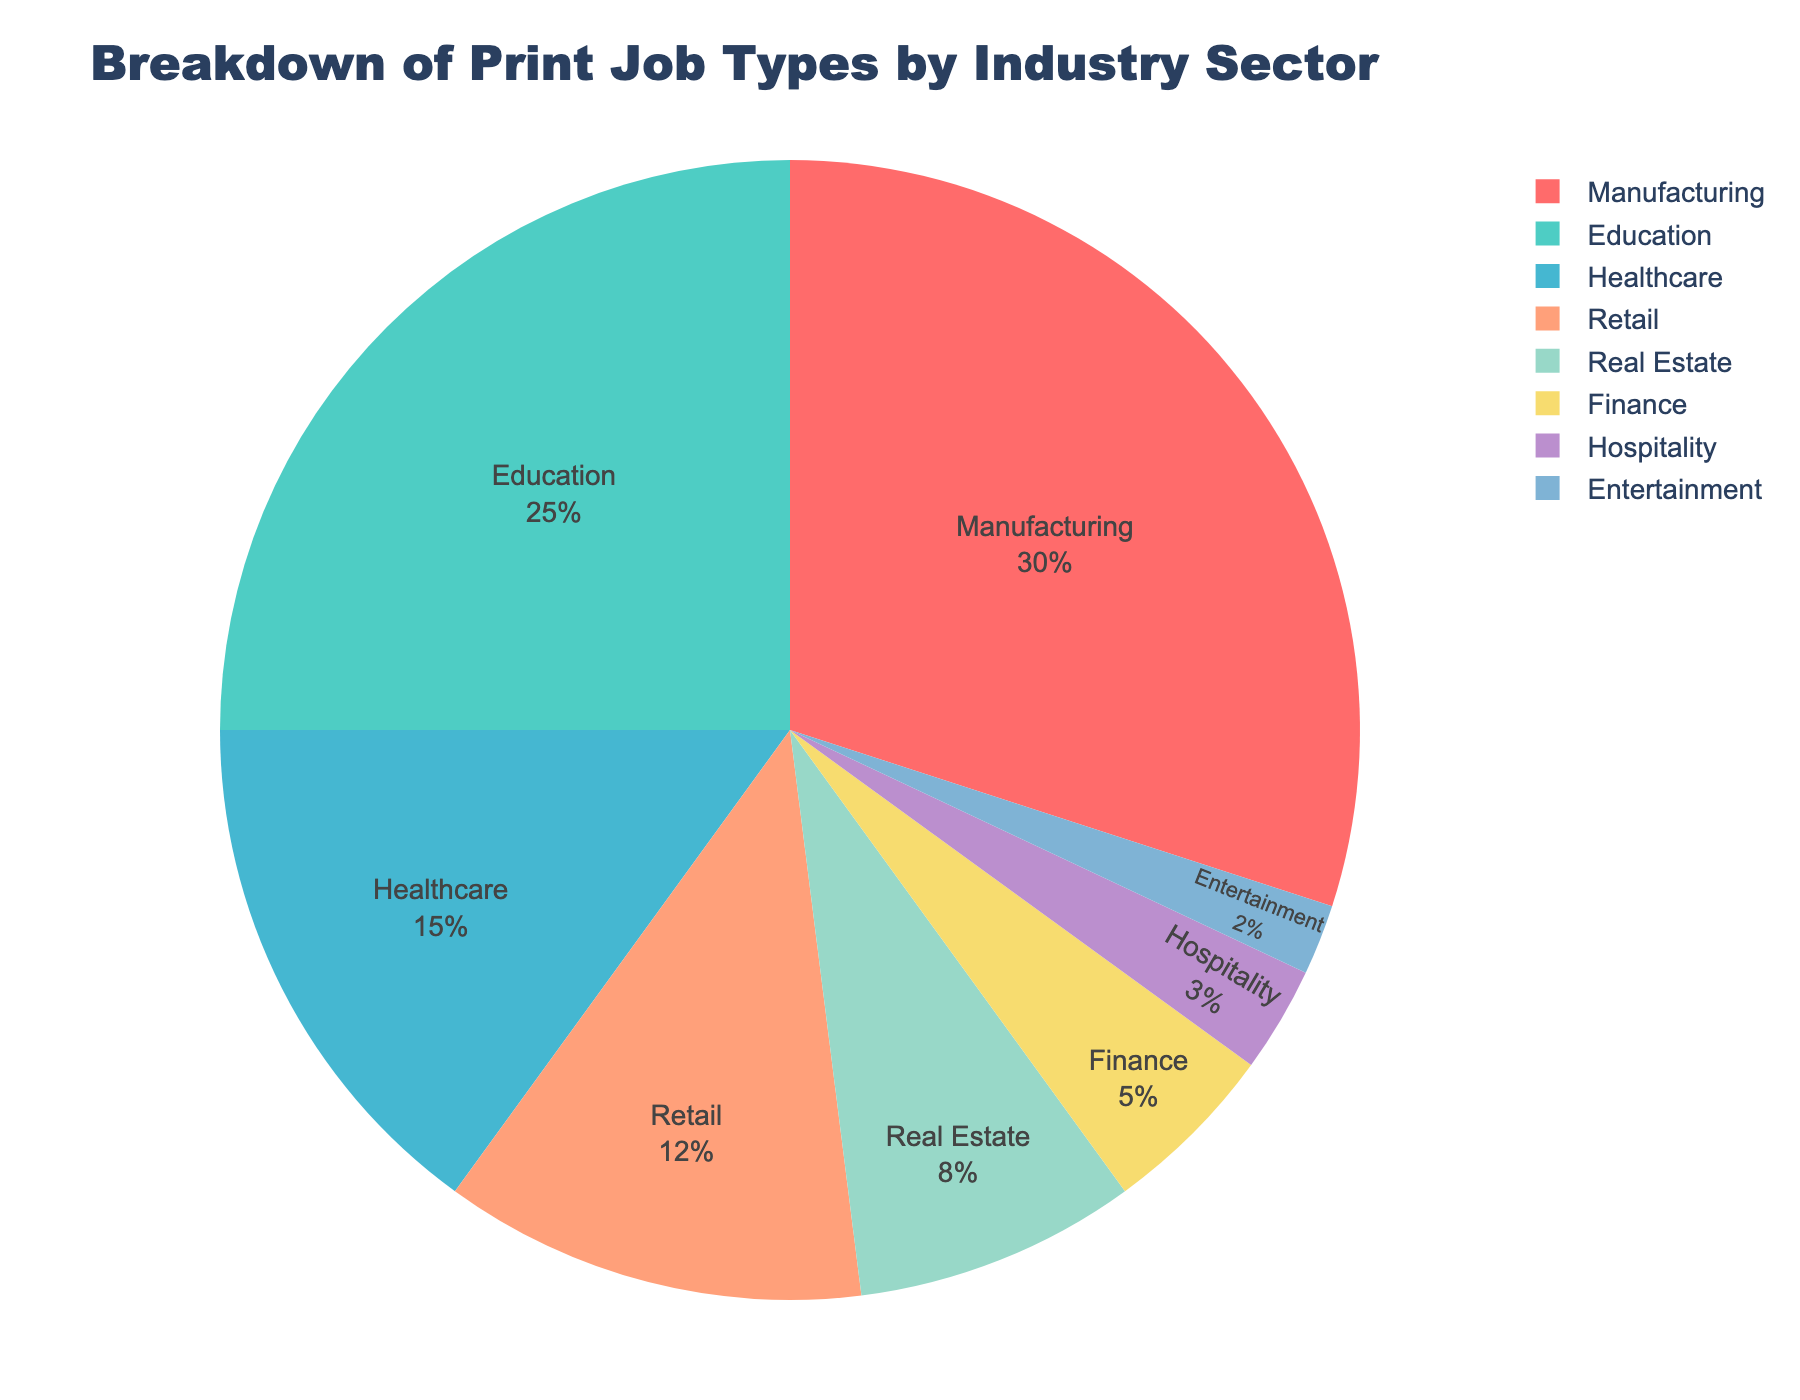What is the title of the chart? The title is usually displayed prominently at the top of the chart.
Answer: Breakdown of Print Job Types by Industry Sector Which industry has the highest percentage of print jobs? 🏭 Look for the section with the largest size in the pie chart; it represents the highest percentage.
Answer: Manufacturing What is the percentage of print jobs for the education sector? 🏫 Find the segment labeled Education and note the associated percentage.
Answer: 25% How much larger is the percentage of product labels in manufacturing than promotional flyers in retail? 🏭 vs. 🏪 Subtract the percentage of promotional flyers from the percentage of product labels.
Answer: 30% - 12% = 18% Which industry has fewer print jobs: entertainment 🎭 or finance 💼? Compare the sizes of the segments labeled Entertainment and Finance; the smaller segment has fewer print jobs.
Answer: Entertainment What job type is predominant in the healthcare sector? 🏥 Hover over or look closely at the healthcare segment to identify the associated job type.
Answer: Medical Forms If we combine the percentages of real estate and finance sectors, what is the total? 🏡 + 💼 Add the percentages of both sectors together.
Answer: 8% + 5% = 13% How does the percentage of textbooks print jobs compare between the education 🏫 and healthcare sectors 🏥? Find the percentage for each sector and compare them.
Answer: Education has a higher percentage (25% vs. 15%) What job type does the retail sector predominantly print? 🏪 Hover over or examine closely the section that represents retail to find the job type.
Answer: Promotional Flyers Which industry has the smallest percentage of print jobs, and what is that percentage? 🎭 Identify the smallest segment and read its percentage.
Answer: Entertainment, 2% 